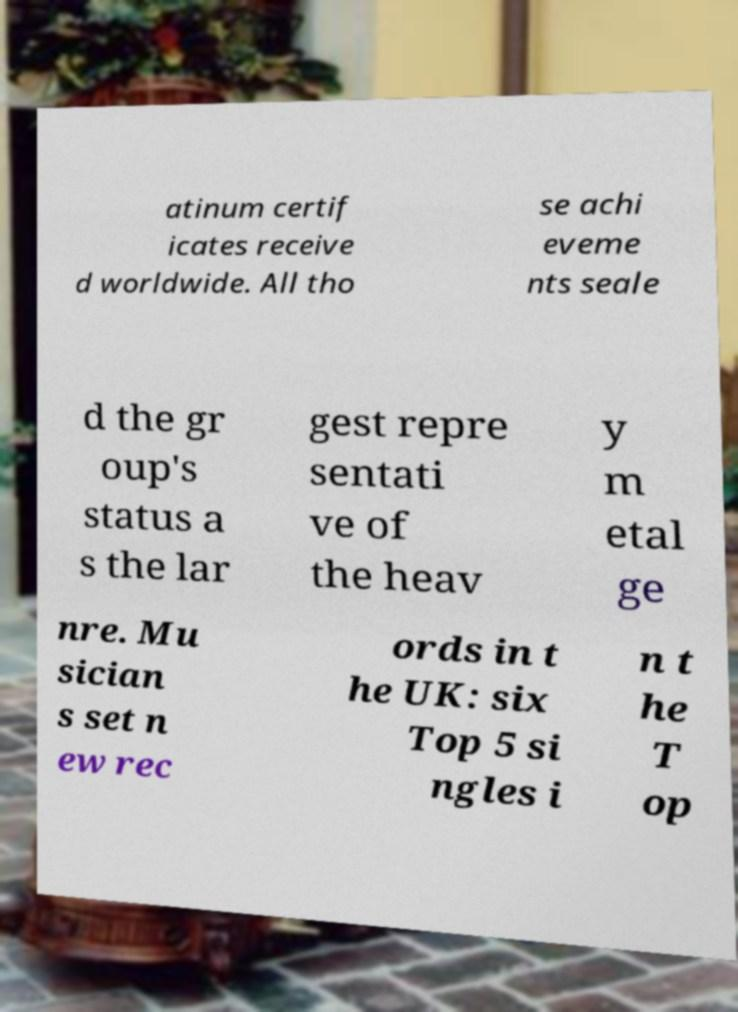Could you extract and type out the text from this image? atinum certif icates receive d worldwide. All tho se achi eveme nts seale d the gr oup's status a s the lar gest repre sentati ve of the heav y m etal ge nre. Mu sician s set n ew rec ords in t he UK: six Top 5 si ngles i n t he T op 